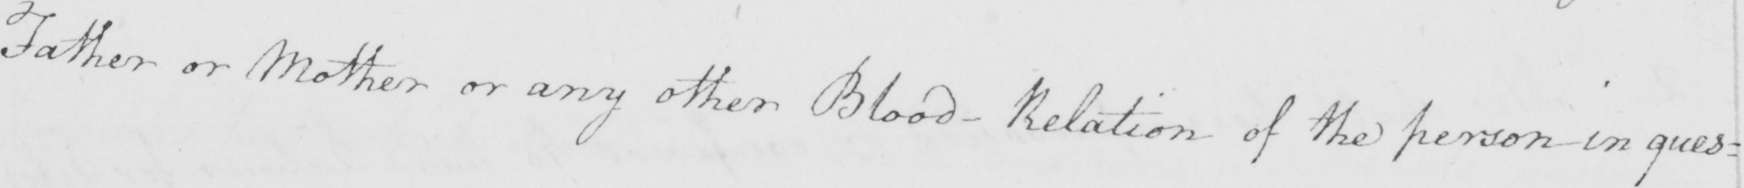What text is written in this handwritten line? Father or Mother or any other Blood-Relation of the person in ques= 